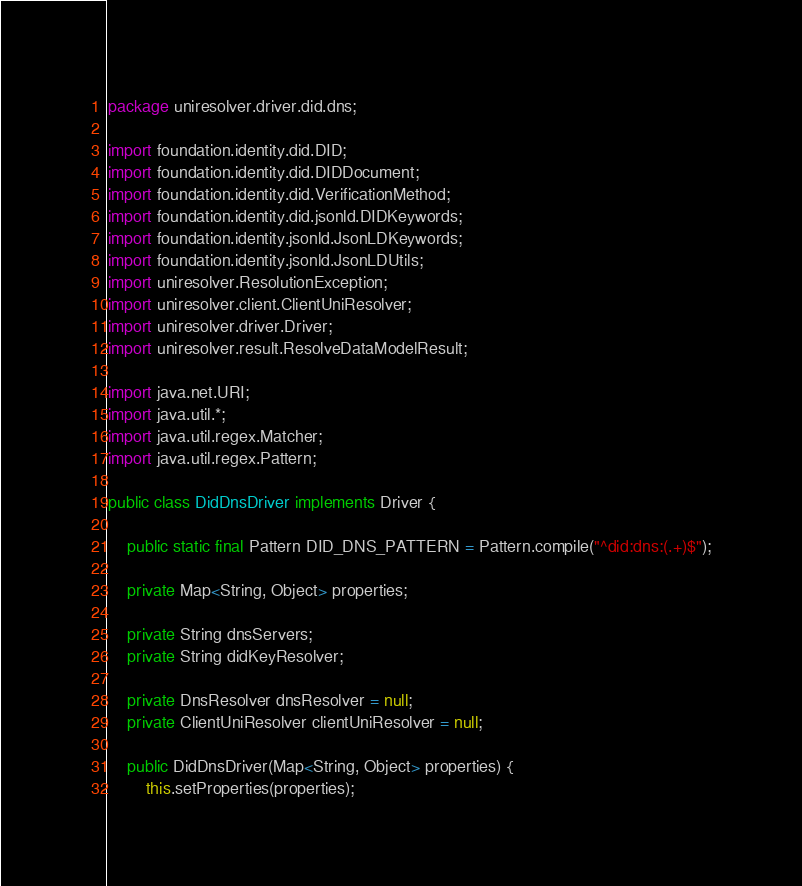Convert code to text. <code><loc_0><loc_0><loc_500><loc_500><_Java_>package uniresolver.driver.did.dns;

import foundation.identity.did.DID;
import foundation.identity.did.DIDDocument;
import foundation.identity.did.VerificationMethod;
import foundation.identity.did.jsonld.DIDKeywords;
import foundation.identity.jsonld.JsonLDKeywords;
import foundation.identity.jsonld.JsonLDUtils;
import uniresolver.ResolutionException;
import uniresolver.client.ClientUniResolver;
import uniresolver.driver.Driver;
import uniresolver.result.ResolveDataModelResult;

import java.net.URI;
import java.util.*;
import java.util.regex.Matcher;
import java.util.regex.Pattern;

public class DidDnsDriver implements Driver {

	public static final Pattern DID_DNS_PATTERN = Pattern.compile("^did:dns:(.+)$");

	private Map<String, Object> properties;

	private String dnsServers;
	private String didKeyResolver;

	private DnsResolver dnsResolver = null;
	private ClientUniResolver clientUniResolver = null;

	public DidDnsDriver(Map<String, Object> properties) {
		this.setProperties(properties);</code> 